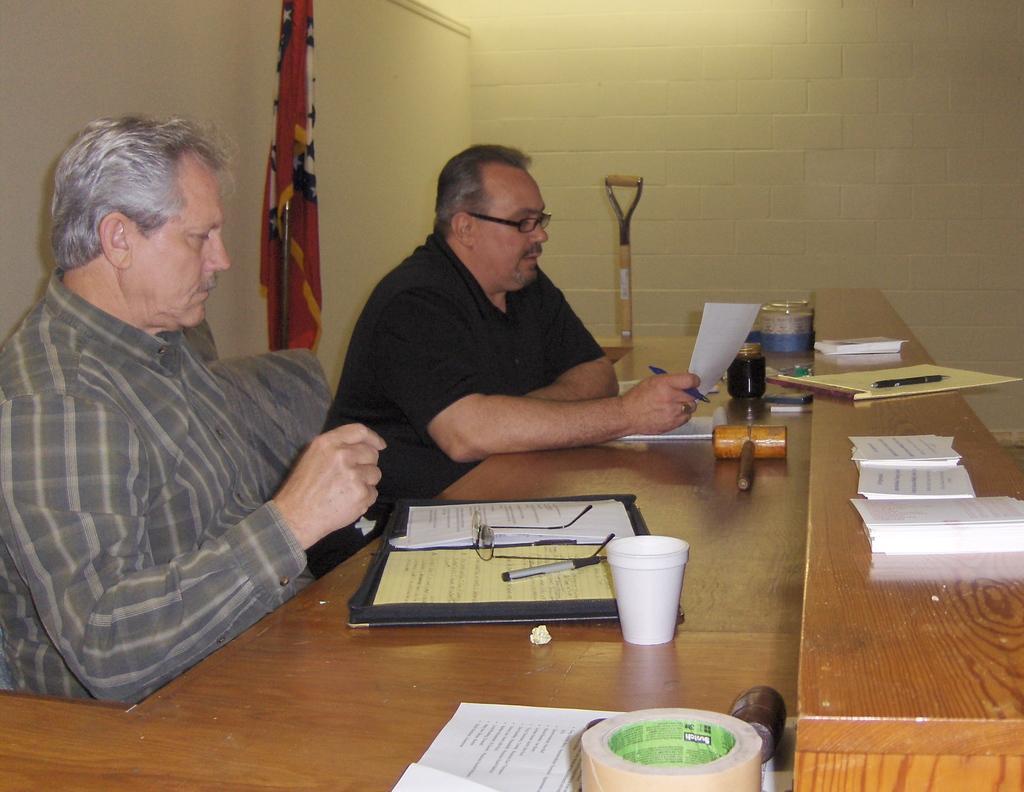Please provide a concise description of this image. There are two men sitting. The men with checks shirt is sitting to the left side. And the men with the black t-shirt is sitting in the right side. In front of them there is a table. On the table there are some files, spectacles, pen, cup, a wooden item bottle, tap. Behind them there is a flag. 